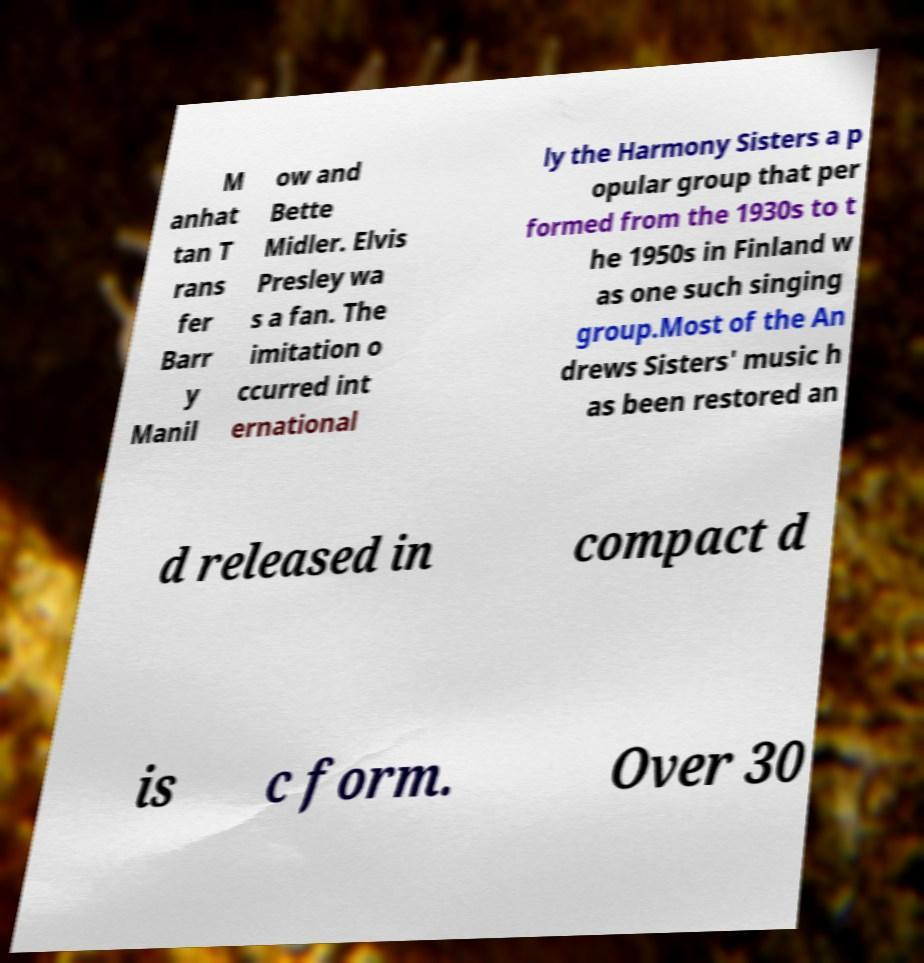Could you assist in decoding the text presented in this image and type it out clearly? M anhat tan T rans fer Barr y Manil ow and Bette Midler. Elvis Presley wa s a fan. The imitation o ccurred int ernational ly the Harmony Sisters a p opular group that per formed from the 1930s to t he 1950s in Finland w as one such singing group.Most of the An drews Sisters' music h as been restored an d released in compact d is c form. Over 30 